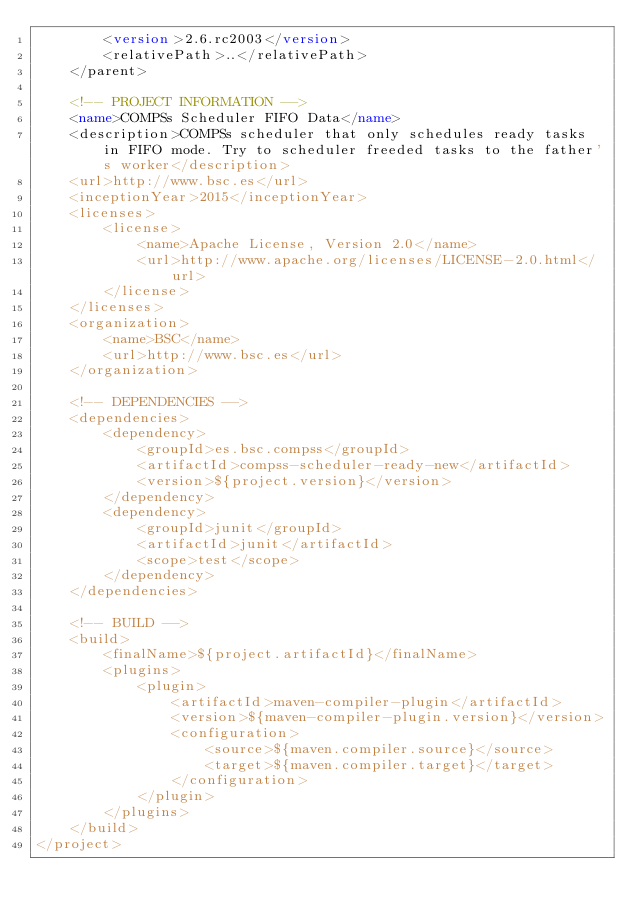<code> <loc_0><loc_0><loc_500><loc_500><_XML_>        <version>2.6.rc2003</version>
        <relativePath>..</relativePath>
    </parent>

    <!-- PROJECT INFORMATION -->
    <name>COMPSs Scheduler FIFO Data</name>
    <description>COMPSs scheduler that only schedules ready tasks in FIFO mode. Try to scheduler freeded tasks to the father's worker</description>
    <url>http://www.bsc.es</url>
    <inceptionYear>2015</inceptionYear>
    <licenses>
        <license>
            <name>Apache License, Version 2.0</name>
            <url>http://www.apache.org/licenses/LICENSE-2.0.html</url>
        </license>
    </licenses>
    <organization>
        <name>BSC</name>
        <url>http://www.bsc.es</url>
    </organization>

    <!-- DEPENDENCIES -->
    <dependencies>
        <dependency>
            <groupId>es.bsc.compss</groupId>
            <artifactId>compss-scheduler-ready-new</artifactId>
            <version>${project.version}</version>
        </dependency>
        <dependency>
            <groupId>junit</groupId>
            <artifactId>junit</artifactId>
            <scope>test</scope>
        </dependency>
    </dependencies>

    <!-- BUILD -->
    <build>
        <finalName>${project.artifactId}</finalName>
        <plugins>
            <plugin>
                <artifactId>maven-compiler-plugin</artifactId>
                <version>${maven-compiler-plugin.version}</version>
                <configuration>
                    <source>${maven.compiler.source}</source>
                    <target>${maven.compiler.target}</target>
                </configuration>
            </plugin>
        </plugins>
    </build>
</project>
</code> 